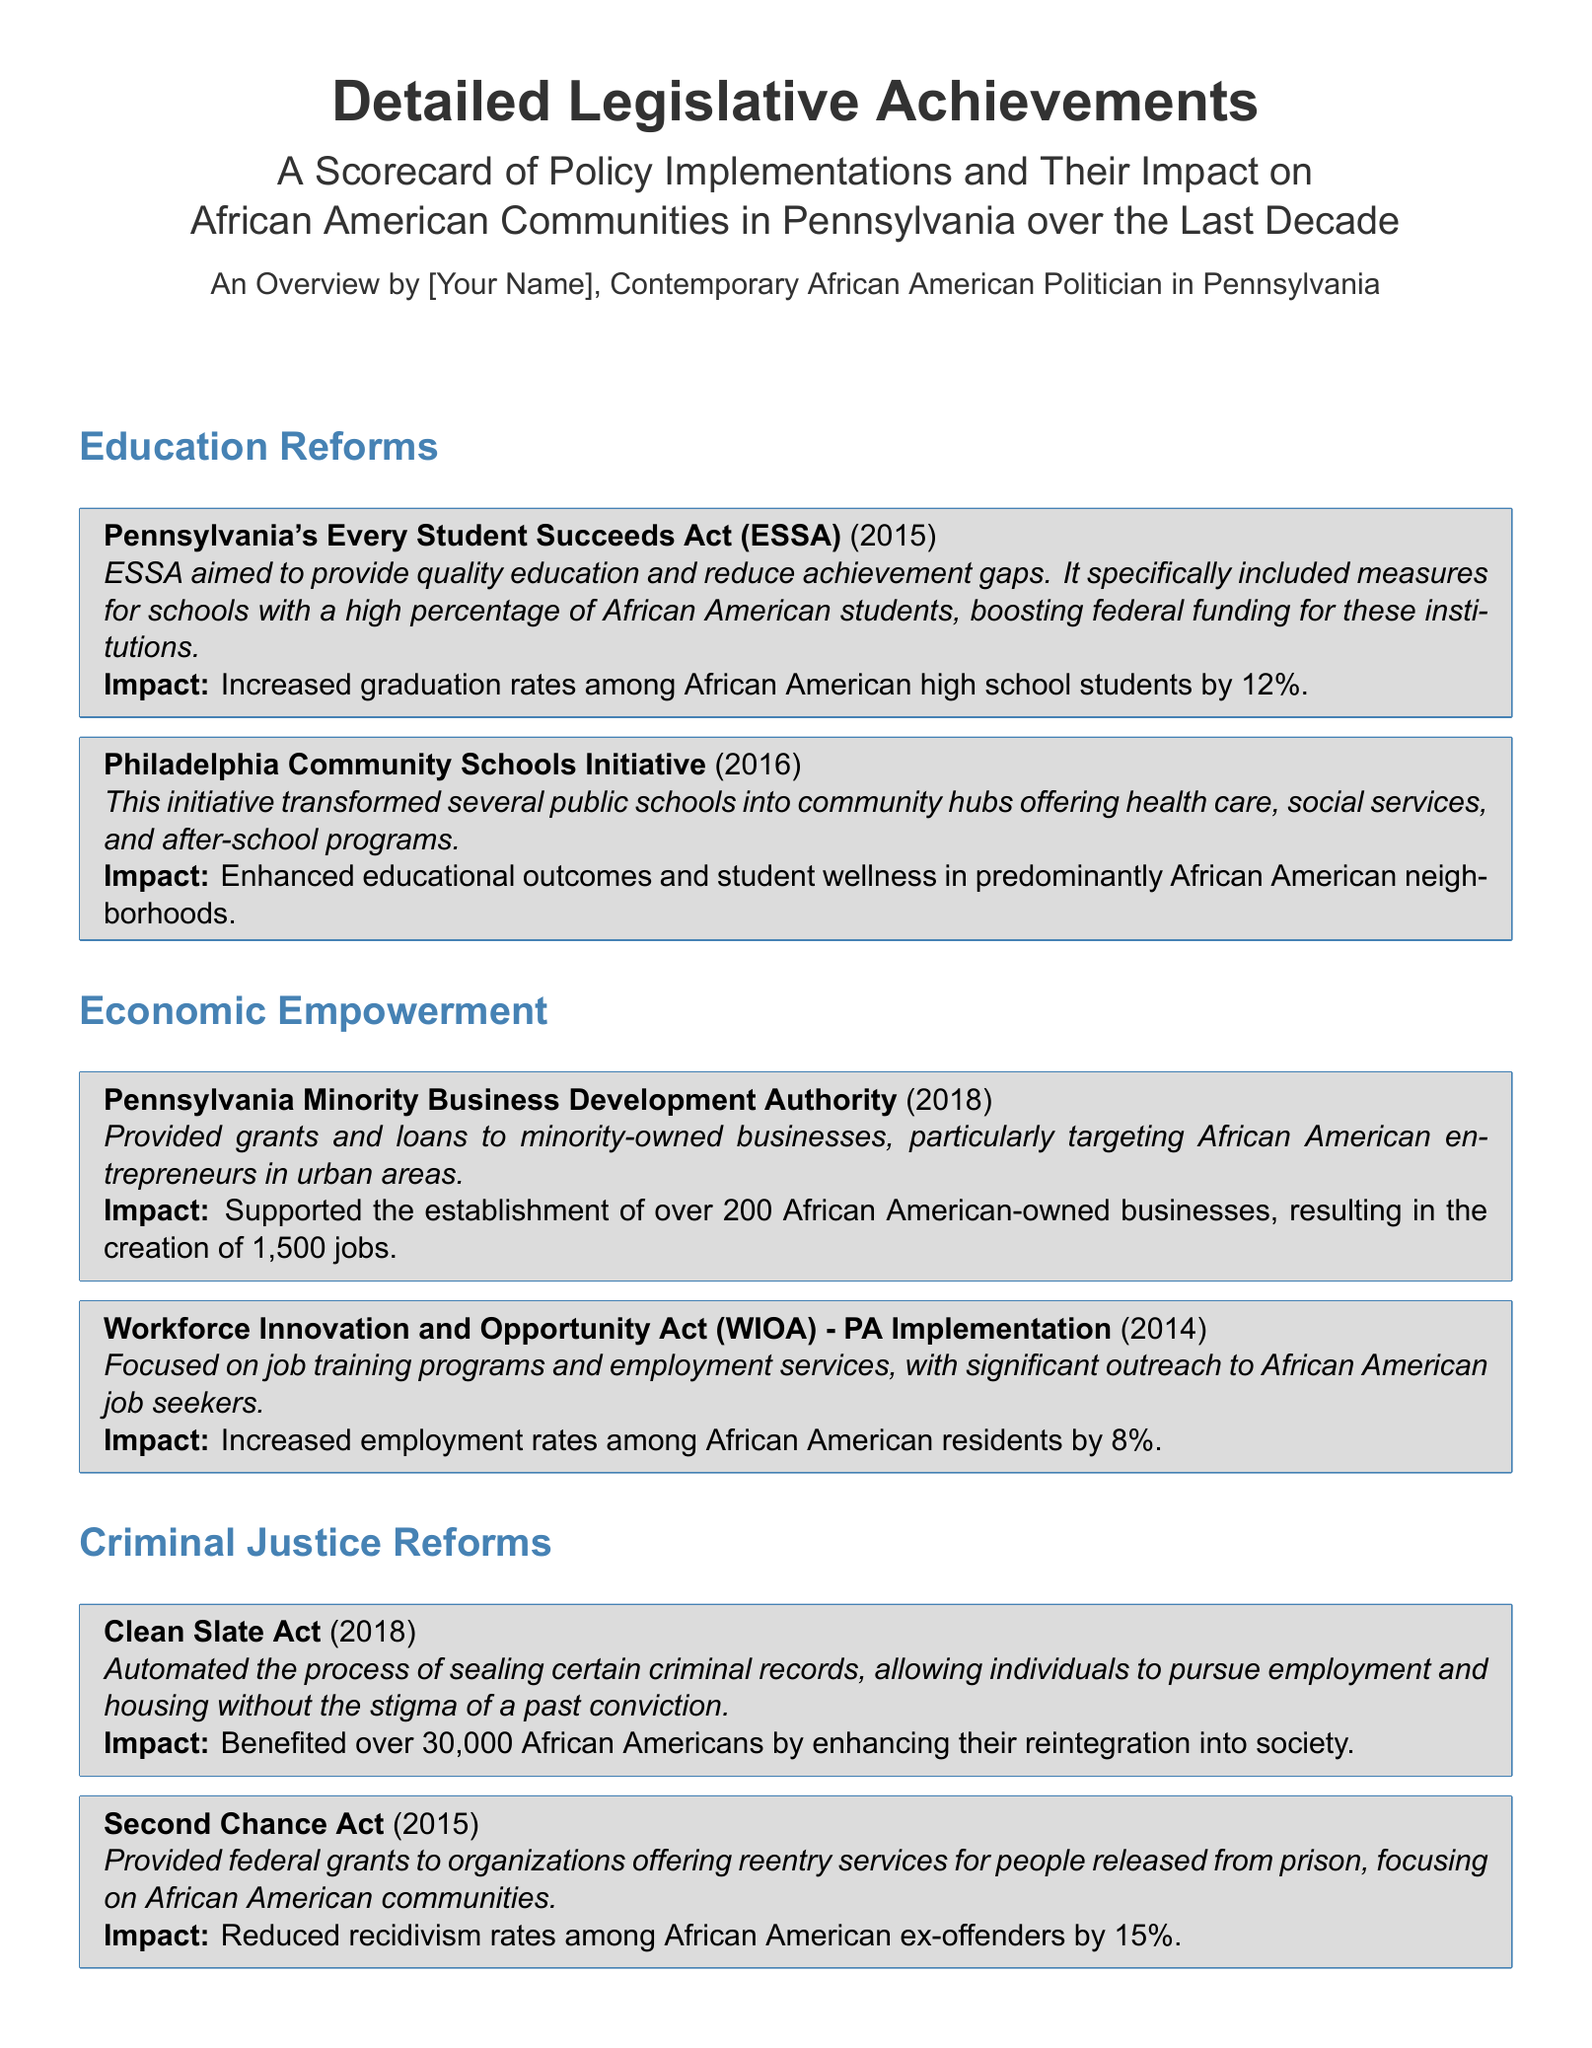What year was the Pennsylvania Every Student Succeeds Act initiated? The ESSA was initiated in the year mentioned in the document.
Answer: 2015 What was the effect of the Philadelphia Community Schools Initiative? The initiative aimed to enhance educational outcomes and student wellness in specific neighborhoods.
Answer: Enhanced educational outcomes and student wellness How many African American-owned businesses were established through the Minority Business Development Authority? The document provides a specific number indicating the businesses supported by the initiative.
Answer: 200 What was the impact of the Clean Slate Act on African Americans? The document indicates a specific benefit to this community as a result of the Clean Slate Act.
Answer: Benefited over 30,000 African Americans What percentage of uninsured African Americans was reduced under Medicaid Expansion? The document specifies a percentage reflecting the impact of Medicaid Expansion.
Answer: 30% How much did employment rates increase for African American residents due to WIOA? The document gives a specific percentage increase in employment rates for this demographic.
Answer: 8% Which act provided federal grants for reentry services? The document explicitly names the act that offers support for reentry services.
Answer: Second Chance Act What was the recidivism rate reduction attributed to the Second Chance Act? The document mentions a specific percentage related to recidivism rates.
Answer: 15% 